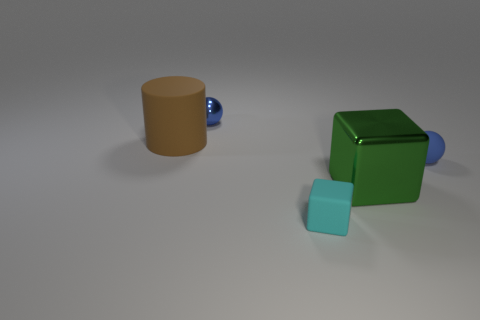Is the color of the ball that is on the right side of the large block the same as the metal ball?
Your answer should be very brief. Yes. How many yellow shiny cubes have the same size as the blue rubber thing?
Provide a short and direct response. 0. There is a rubber object that is the same color as the metallic ball; what is its size?
Your answer should be compact. Small. Is the small metallic thing the same color as the small rubber sphere?
Offer a very short reply. Yes. What is the shape of the blue shiny object?
Provide a short and direct response. Sphere. Is there a matte object of the same color as the tiny metal thing?
Your response must be concise. Yes. Is the number of shiny objects to the left of the tiny matte sphere greater than the number of blue rubber objects?
Give a very brief answer. Yes. Is the shape of the tiny cyan thing the same as the metallic thing that is to the right of the tiny cyan thing?
Ensure brevity in your answer.  Yes. Is there a brown cylinder?
Ensure brevity in your answer.  Yes. How many big objects are either yellow things or rubber spheres?
Provide a short and direct response. 0. 